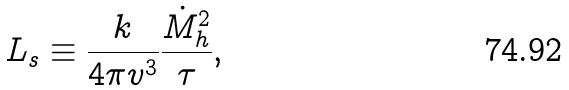<formula> <loc_0><loc_0><loc_500><loc_500>L _ { s } \equiv \frac { k } { 4 \pi v ^ { 3 } } \frac { \dot { M } _ { h } ^ { 2 } } { \tau } ,</formula> 